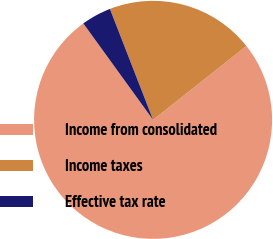Convert chart to OTSL. <chart><loc_0><loc_0><loc_500><loc_500><pie_chart><fcel>Income from consolidated<fcel>Income taxes<fcel>Effective tax rate<nl><fcel>75.69%<fcel>20.25%<fcel>4.06%<nl></chart> 